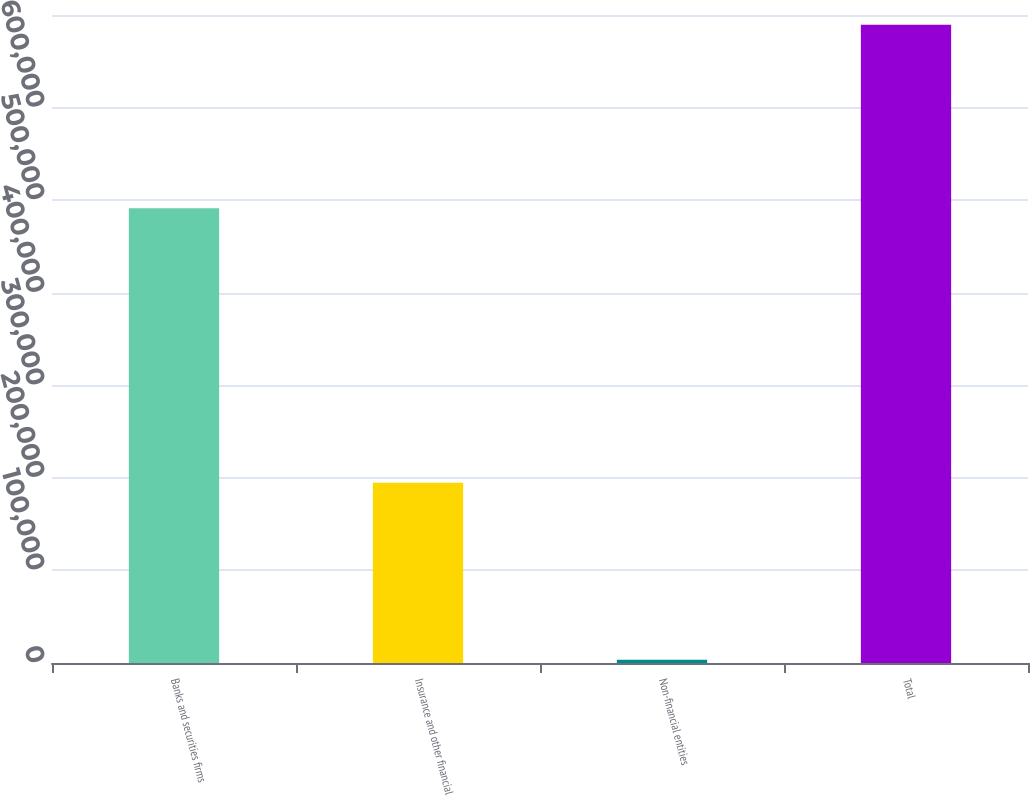Convert chart to OTSL. <chart><loc_0><loc_0><loc_500><loc_500><bar_chart><fcel>Banks and securities firms<fcel>Insurance and other financial<fcel>Non-financial entities<fcel>Total<nl><fcel>491267<fcel>194723<fcel>3529<fcel>689519<nl></chart> 